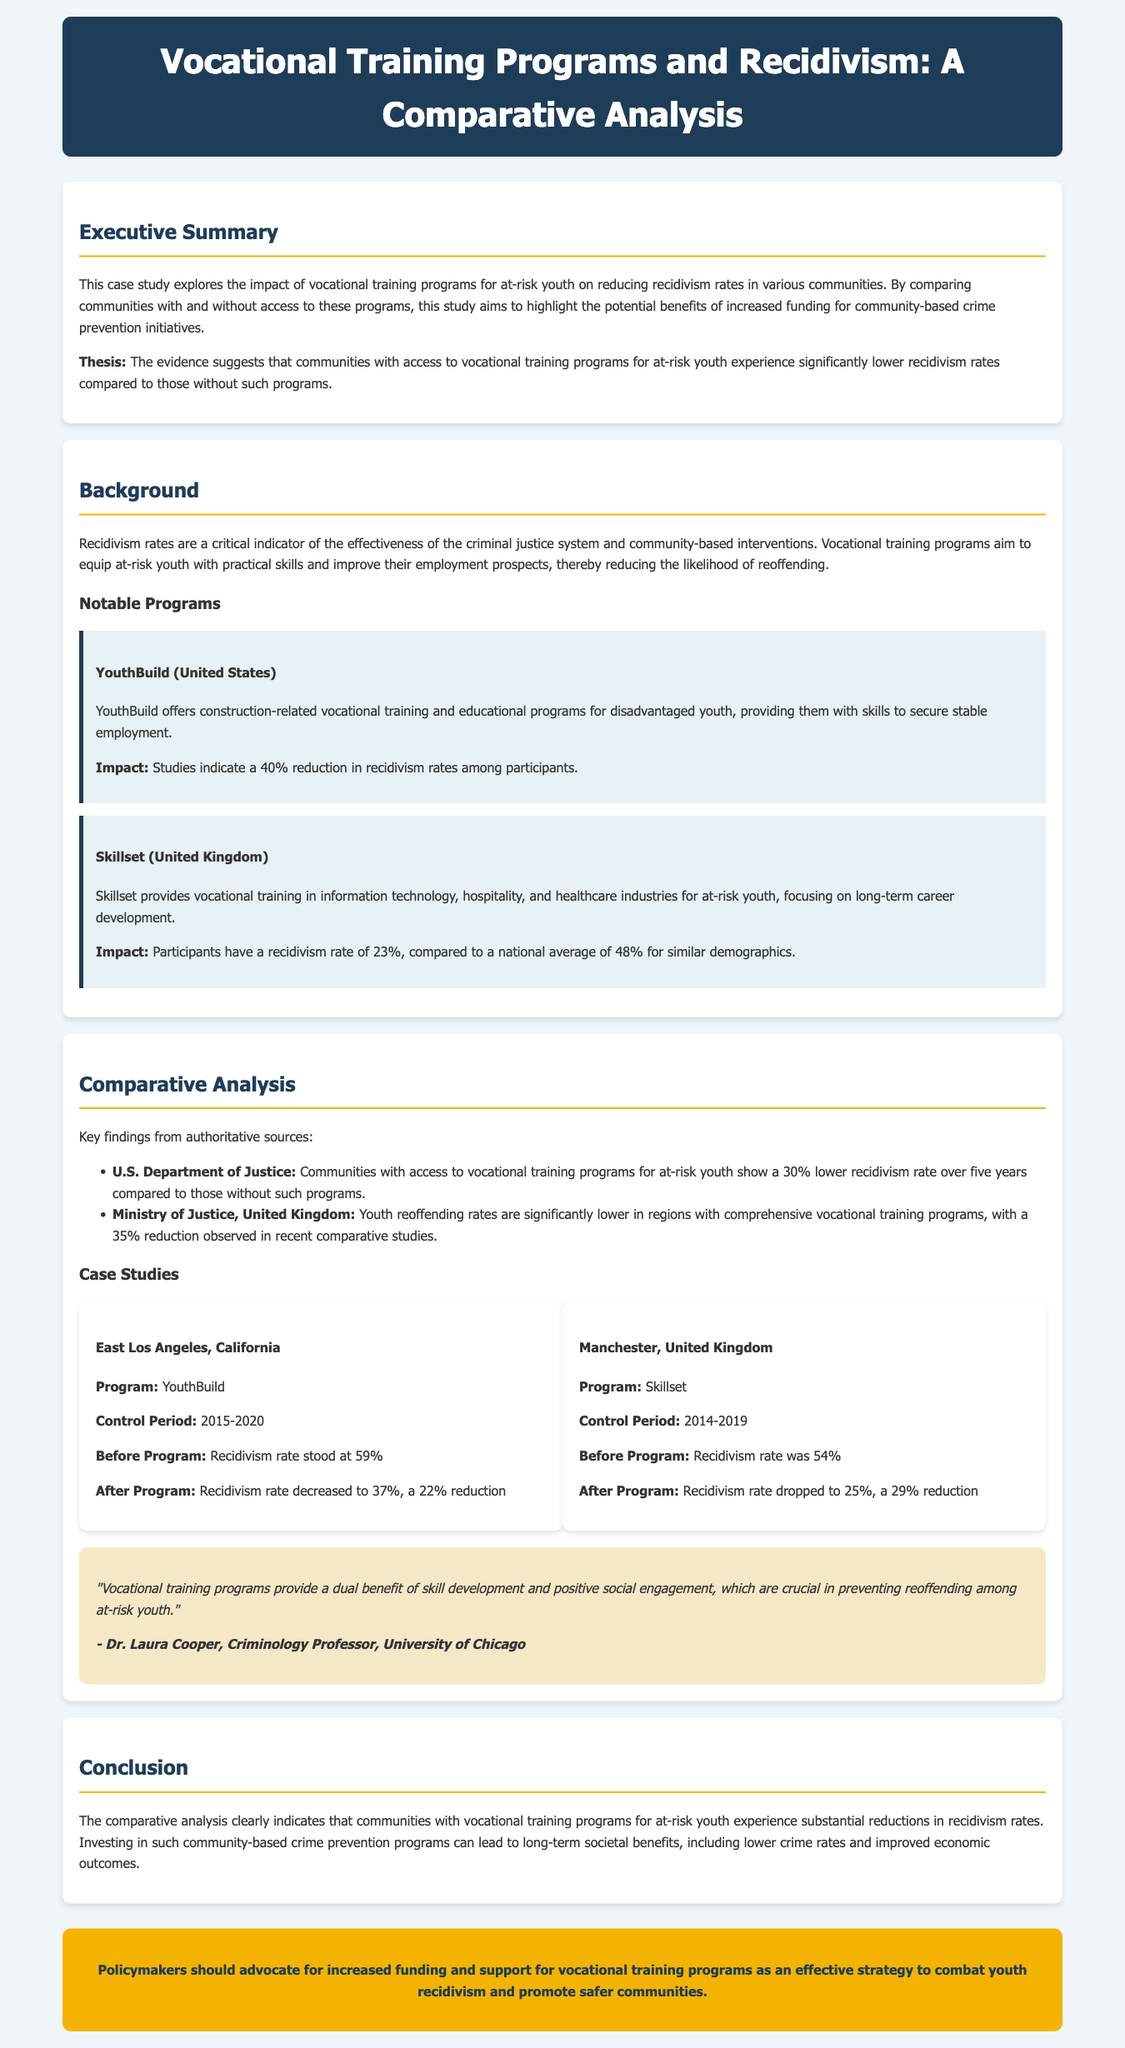what is the primary focus of the case study? The case study focuses on the impact of vocational training programs for at-risk youth on reducing recidivism rates.
Answer: impact of vocational training programs what percentage reduction in recidivism is indicated for the YouthBuild program? The YouthBuild program is associated with a 40% reduction in recidivism rates among participants.
Answer: 40% what was the recidivism rate before the Skillset program in Manchester? The recidivism rate before the Skillset program was 54%.
Answer: 54% who is the expert quoted in the document? Dr. Laura Cooper, a Criminology Professor at the University of Chicago, is quoted in the document.
Answer: Dr. Laura Cooper what was the recidivism rate after the program in East Los Angeles? After the program in East Los Angeles, the recidivism rate decreased to 37%.
Answer: 37% how much lower is the recidivism rate in communities with vocational training, according to the U.S. Department of Justice? According to the U.S. Department of Justice, there is a 30% lower recidivism rate in communities with vocational training programs.
Answer: 30% what does the case study suggest about community-based crime prevention programs? The case study suggests advocating for increased funding for community-based crime prevention programs.
Answer: increased funding what is the duration of the control period for the YouthBuild case study? The control period for the YouthBuild case study is from 2015 to 2020.
Answer: 2015-2020 